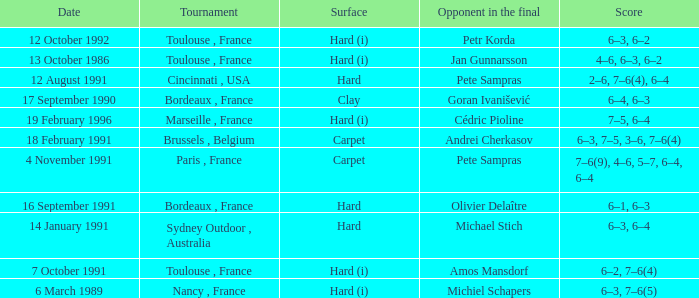What is the score of the tournament with olivier delaître as the opponent in the final? 6–1, 6–3. 